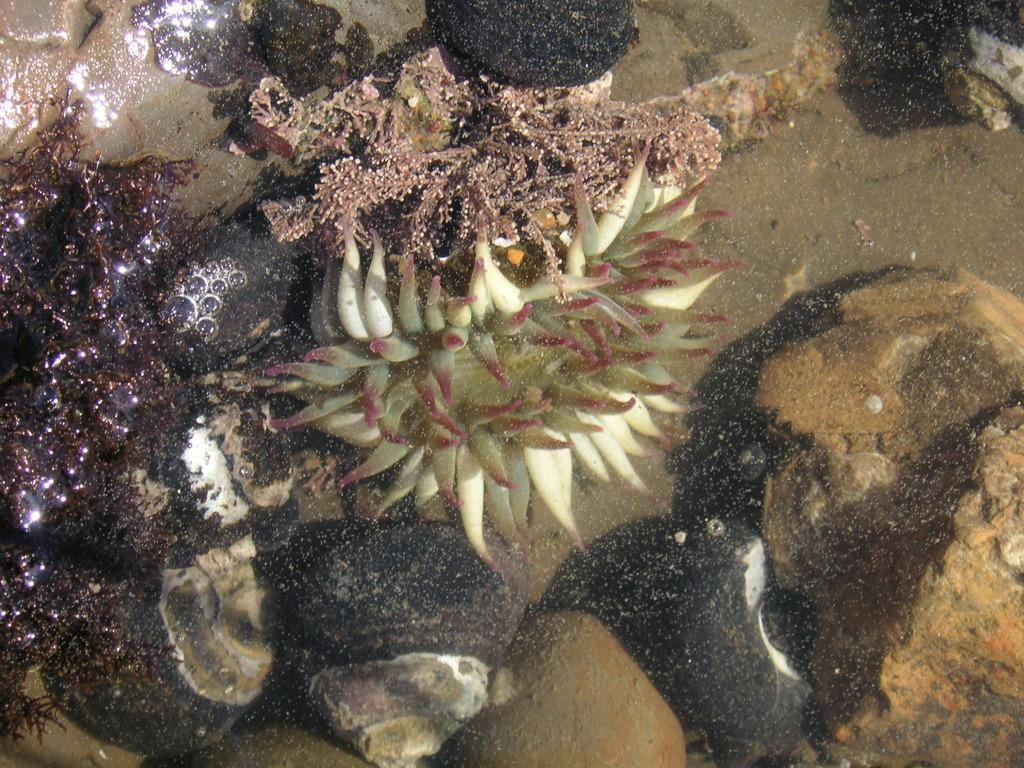What type of plants are present in the image? There are aquatic plants in the image. Can you describe the colors of the aquatic plants? The aquatic plants have different colors. What else can be seen in the image besides the plants? There are stones visible in the image. What is the primary environment depicted in the image? There is water visible in the image, suggesting an aquatic environment. What type of border can be seen around the aquatic plants in the image? There is no border visible around the aquatic plants in the image. Can you describe the car that is parked near the aquatic plants in the image? There are no cars present in the image; it features aquatic plants, stones, and water. 